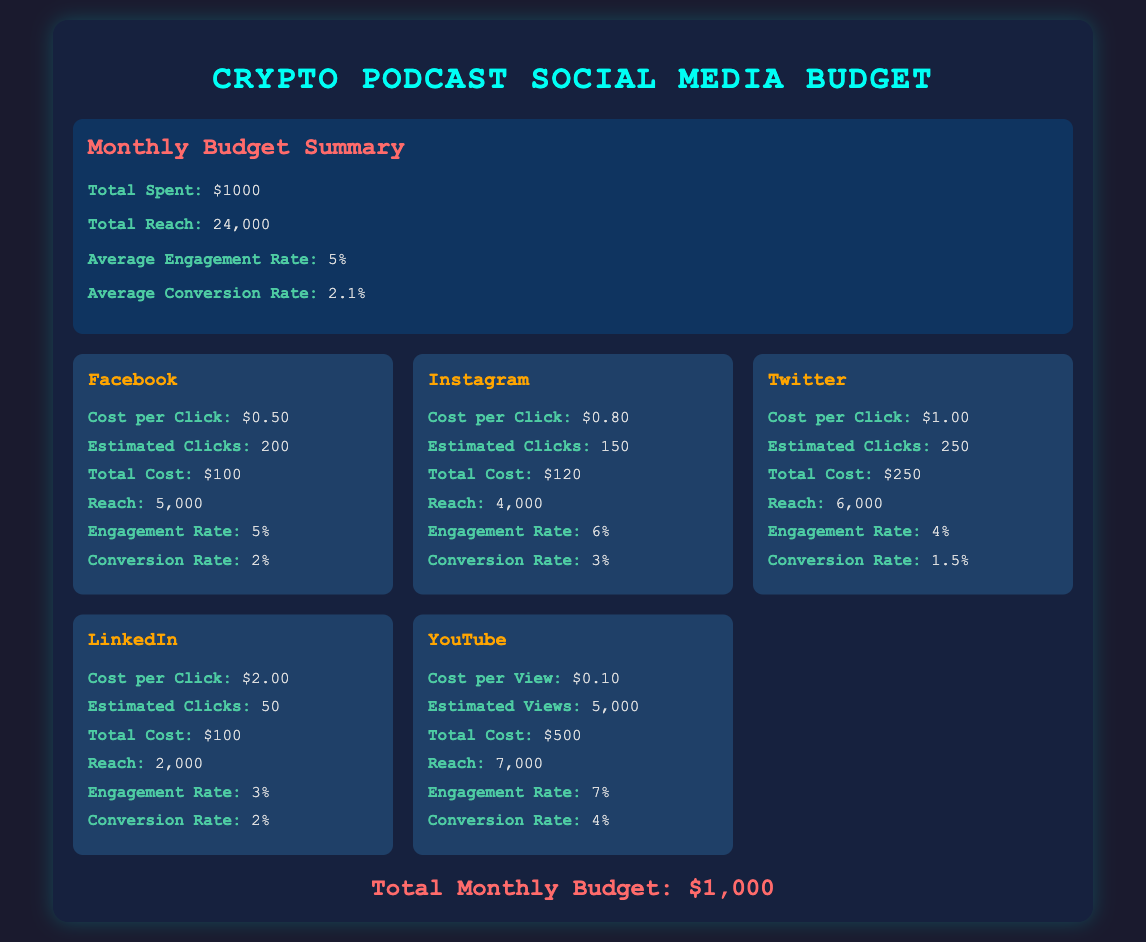What is the total monthly budget? The total monthly budget is indicated at the bottom of the document.
Answer: $1,000 What is the engagement rate for Instagram? The engagement rate for Instagram is found within its platform card.
Answer: 6% How many estimated clicks are there for Twitter? The estimated clicks for Twitter are stated in the Twitter platform card.
Answer: 250 What is the total reach across all platforms? The total reach is the sum of reach from each platform; the document lists individual platform reach.
Answer: 24,000 What is the cost per view on YouTube? The cost per view is specified in the YouTube platform card.
Answer: $0.10 Which platform has the highest engagement rate? This requires comparing engagement rates across all platforms, which are presented in their respective cards.
Answer: YouTube What is the conversion rate for LinkedIn? The conversion rate for LinkedIn can be found in the platform card.
Answer: 2% What is the total cost for advertising on Facebook? The total cost for advertising on Facebook is indicated in the Facebook platform card.
Answer: $100 How much is spent on advertising in total on Twitter? The total cost on Twitter is presented directly in its respective card.
Answer: $250 